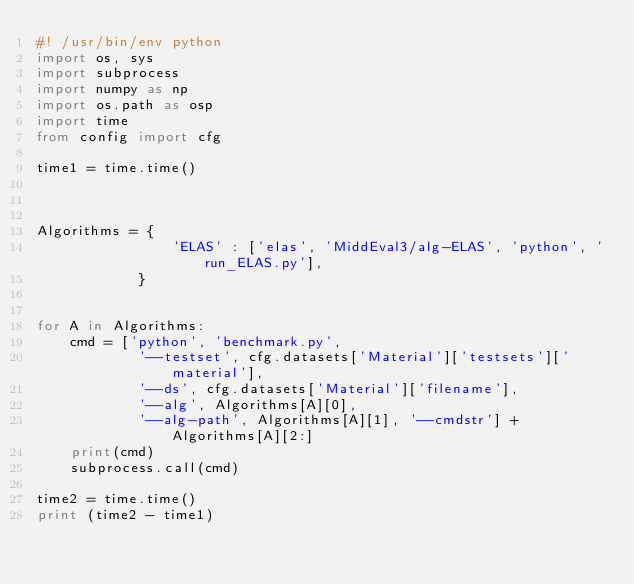<code> <loc_0><loc_0><loc_500><loc_500><_Python_>#! /usr/bin/env python
import os, sys
import subprocess
import numpy as np
import os.path as osp
import time
from config import cfg

time1 = time.time()



Algorithms = {  
				'ELAS' : ['elas', 'MiddEval3/alg-ELAS', 'python', 'run_ELAS.py'],
			}


for A in Algorithms:
	cmd = ['python', 'benchmark.py',
			'--testset', cfg.datasets['Material']['testsets']['material'],
			'--ds', cfg.datasets['Material']['filename'],
			'--alg', Algorithms[A][0],
			'--alg-path', Algorithms[A][1], '--cmdstr'] + Algorithms[A][2:]
	print(cmd)
	subprocess.call(cmd)

time2 = time.time()
print (time2 - time1)
</code> 